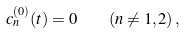<formula> <loc_0><loc_0><loc_500><loc_500>c _ { n } ^ { ( 0 ) } ( t ) = 0 \quad ( n \neq 1 , 2 ) \, ,</formula> 